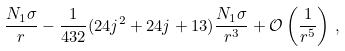Convert formula to latex. <formula><loc_0><loc_0><loc_500><loc_500>\frac { N _ { 1 } \sigma } { r } - \frac { 1 } { 4 3 2 } ( 2 4 j ^ { 2 } + 2 4 j + 1 3 ) \frac { N _ { 1 } \sigma } { r ^ { 3 } } + \mathcal { O } \left ( \frac { 1 } { r ^ { 5 } } \right ) \, ,</formula> 